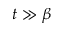Convert formula to latex. <formula><loc_0><loc_0><loc_500><loc_500>t \gg \beta</formula> 